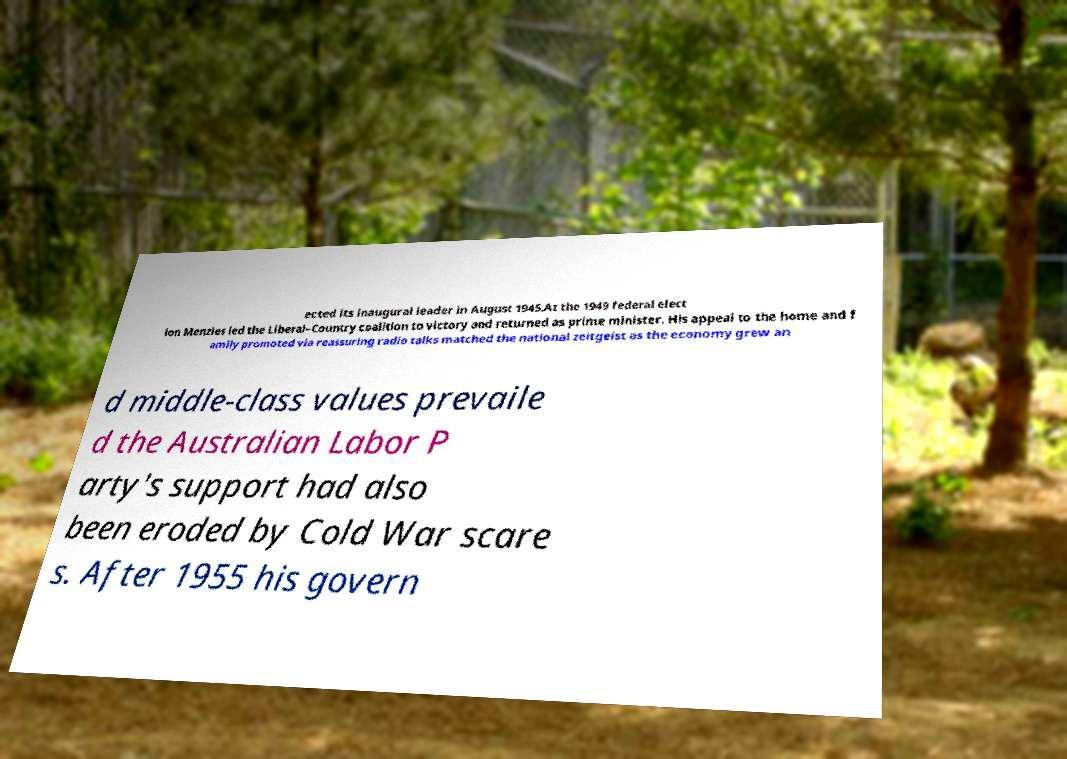Please identify and transcribe the text found in this image. ected its inaugural leader in August 1945.At the 1949 federal elect ion Menzies led the Liberal–Country coalition to victory and returned as prime minister. His appeal to the home and f amily promoted via reassuring radio talks matched the national zeitgeist as the economy grew an d middle-class values prevaile d the Australian Labor P arty's support had also been eroded by Cold War scare s. After 1955 his govern 